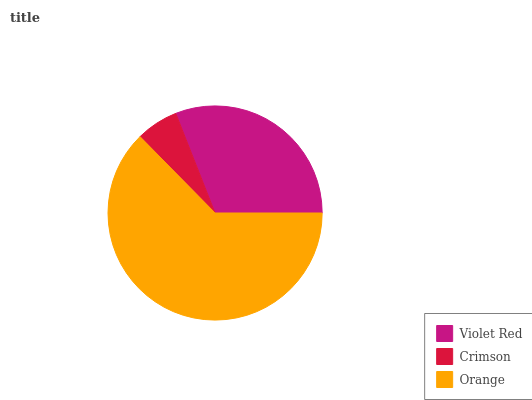Is Crimson the minimum?
Answer yes or no. Yes. Is Orange the maximum?
Answer yes or no. Yes. Is Orange the minimum?
Answer yes or no. No. Is Crimson the maximum?
Answer yes or no. No. Is Orange greater than Crimson?
Answer yes or no. Yes. Is Crimson less than Orange?
Answer yes or no. Yes. Is Crimson greater than Orange?
Answer yes or no. No. Is Orange less than Crimson?
Answer yes or no. No. Is Violet Red the high median?
Answer yes or no. Yes. Is Violet Red the low median?
Answer yes or no. Yes. Is Orange the high median?
Answer yes or no. No. Is Crimson the low median?
Answer yes or no. No. 